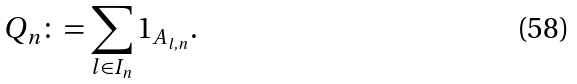Convert formula to latex. <formula><loc_0><loc_0><loc_500><loc_500>Q _ { n } \colon = \sum _ { l \in I _ { n } } 1 _ { A _ { l , n } } .</formula> 